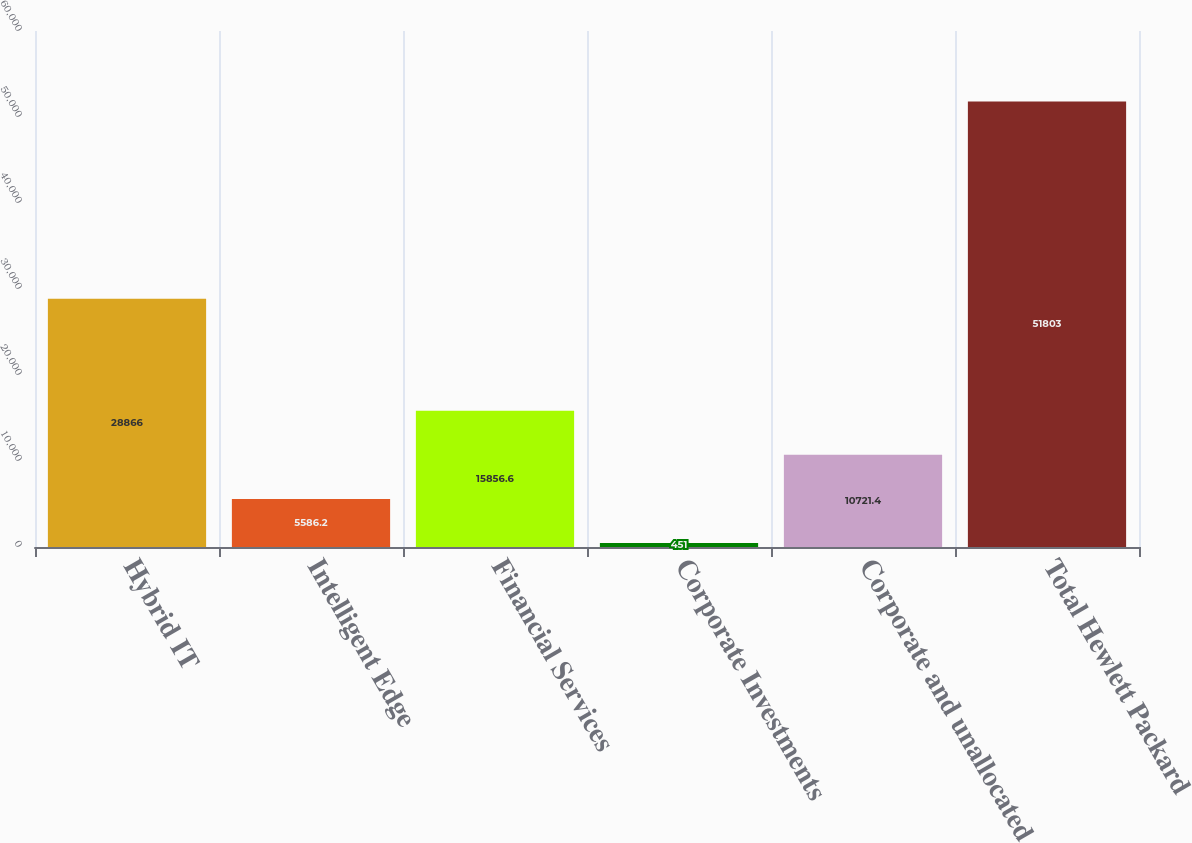<chart> <loc_0><loc_0><loc_500><loc_500><bar_chart><fcel>Hybrid IT<fcel>Intelligent Edge<fcel>Financial Services<fcel>Corporate Investments<fcel>Corporate and unallocated<fcel>Total Hewlett Packard<nl><fcel>28866<fcel>5586.2<fcel>15856.6<fcel>451<fcel>10721.4<fcel>51803<nl></chart> 